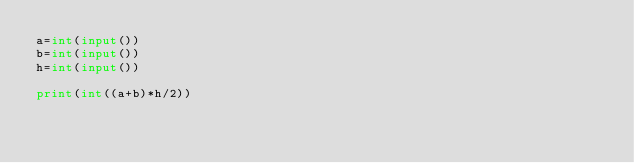<code> <loc_0><loc_0><loc_500><loc_500><_Python_>a=int(input())
b=int(input())
h=int(input())

print(int((a+b)*h/2))</code> 